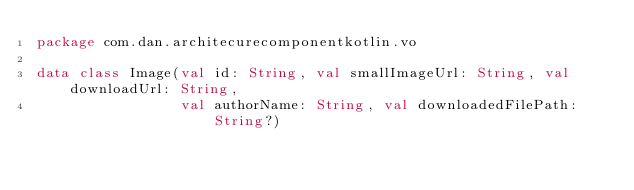<code> <loc_0><loc_0><loc_500><loc_500><_Kotlin_>package com.dan.architecurecomponentkotlin.vo

data class Image(val id: String, val smallImageUrl: String, val downloadUrl: String,
                 val authorName: String, val downloadedFilePath: String?)</code> 